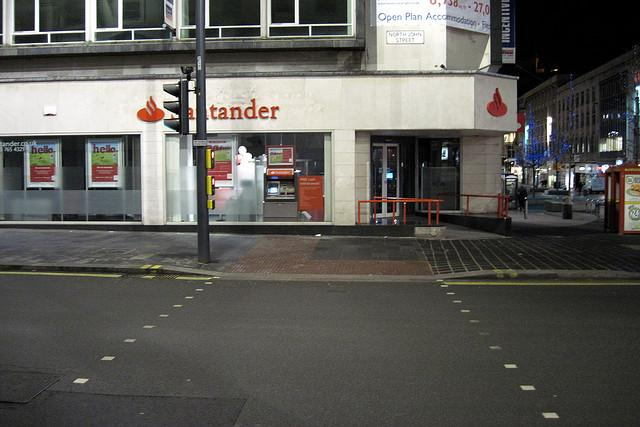What might come from the right or left at any time? Please explain your reasoning. car. A car could pass through this intersection from the right or left at any moment. 